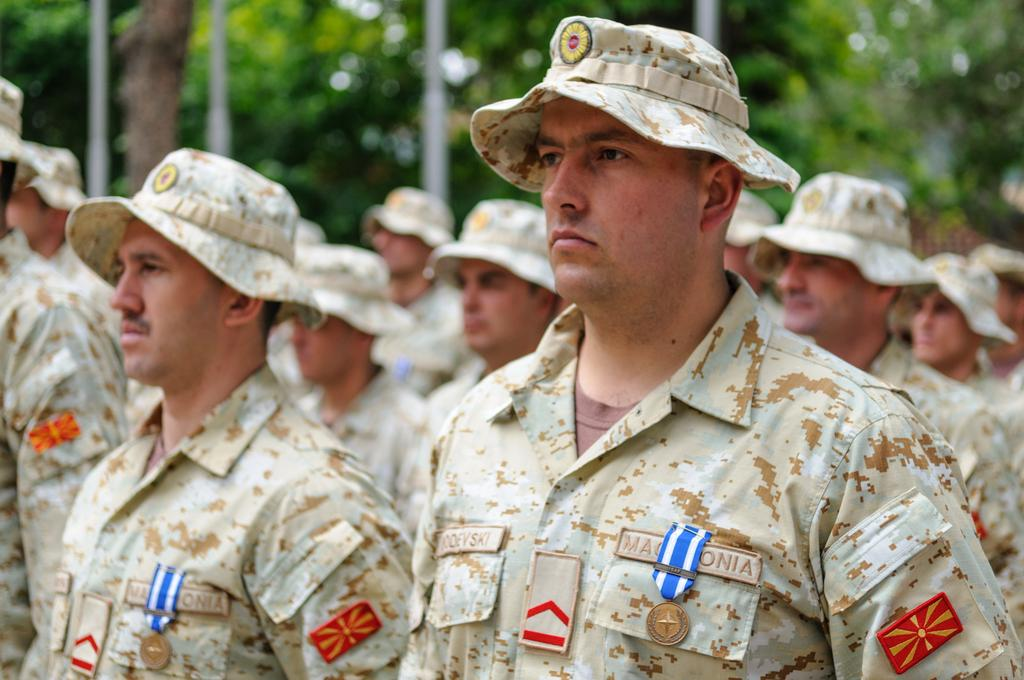What is the main focus of the image? The main focus of the image is the people in the center. What can be seen in the background of the image? There are trees at the top side of the image. What type of attraction can be seen in the image? There is no specific attraction mentioned or visible in the image; it primarily features people and trees. 